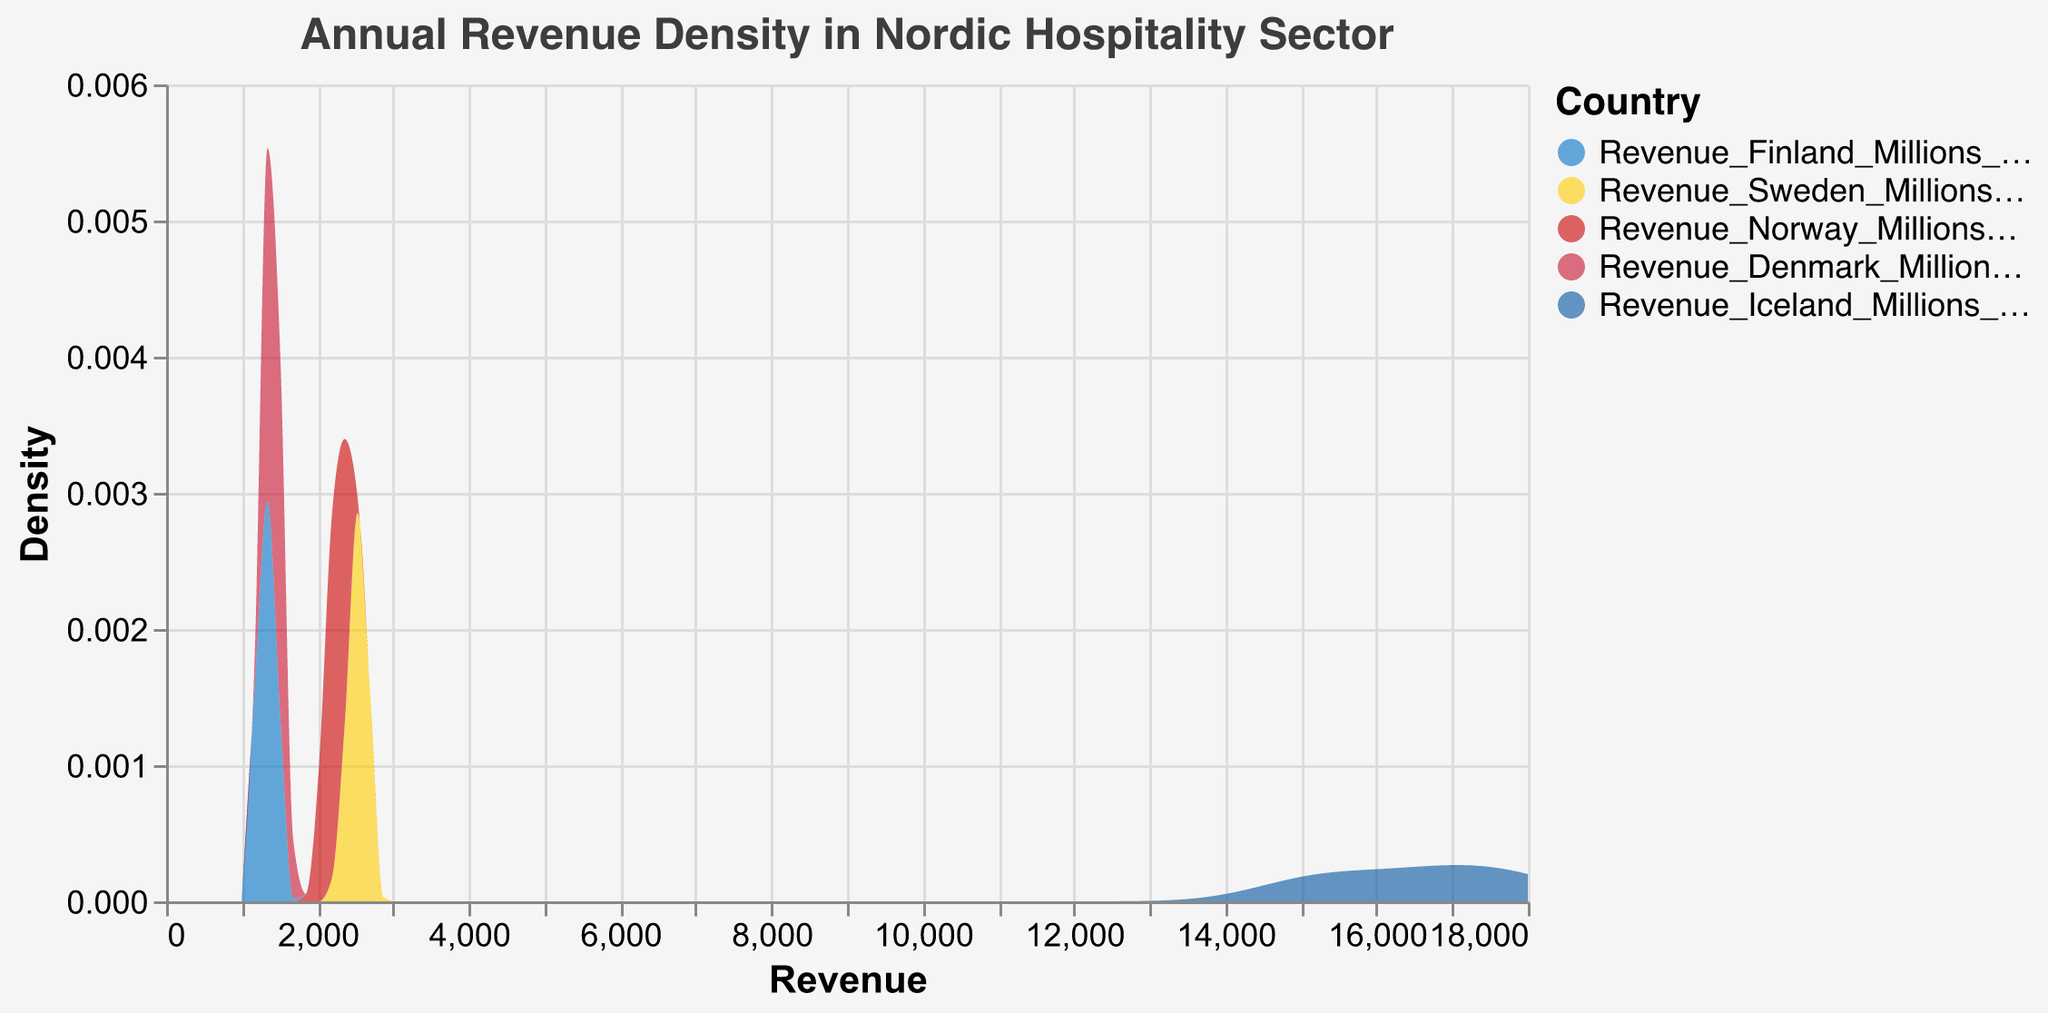Which country shows the highest density peak in revenue? The plots show density peaks for different countries. The country with the highest peak in the density plot is the one with the tallest area.
Answer: Iceland How has Finland's revenue fluctuated over the decade? Finland's revenue is shown to have fluctuation from 1200 million EUR in 2013 to around 1500 million EUR in 2019, a drop to 1200 million EUR in 2020, and then rising again to 1400 million EUR in 2022.
Answer: Fluctuated between 1200 million to 1500 million EUR Which country had the most stable revenue over the years? Stability is indicated by a sharp, narrow density peak. The country with the most stable revenue over the years will have a higher and narrower peak.
Answer: Sweden In which year did most countries see a significant drop in revenue? Look for a year where the density plots of multiple countries have low values. This can be identified as the point where multiple density areas drop or have their lowest values.
Answer: 2020 Which Nordic country shows the most variation in its revenue density plot? The most variation can be identified by a wider and less peaked area in the density plot.
Answer: Iceland What is the general trend in the hospitality sector revenue in Denmark? The density plot will show the range of revenue values over the years. For Denmark, the plot shows a general increase initially and then some fluctuations.
Answer: Initially increasing, then fluctuating Compare the revenue distribution of Norway and Denmark. Which country exhibits more spread (variation) in revenue? Comparison involves looking at the width of the peaks. Wider peaks indicate more variation.
Answer: Denmark What was the range of revenue for Iceland from 2013 to 2022? Check the span of Iceland’s density plot along the revenue axis to see the minimum and maximum revenue values.
Answer: 15000 to 18000 million ISK Did Sweden experience a significant dip in revenue at any point? Look at the density plot for Sweden to check for any noticeable dips or outliers.
Answer: Yes, in 2020 How does 2020's revenue in Finland compare to its revenue in 2022? Compare the peaks of Finland's density plot for 2020 and 2022 to see if the revenue increased or decreased.
Answer: 2020’s revenue was lower than 2022 